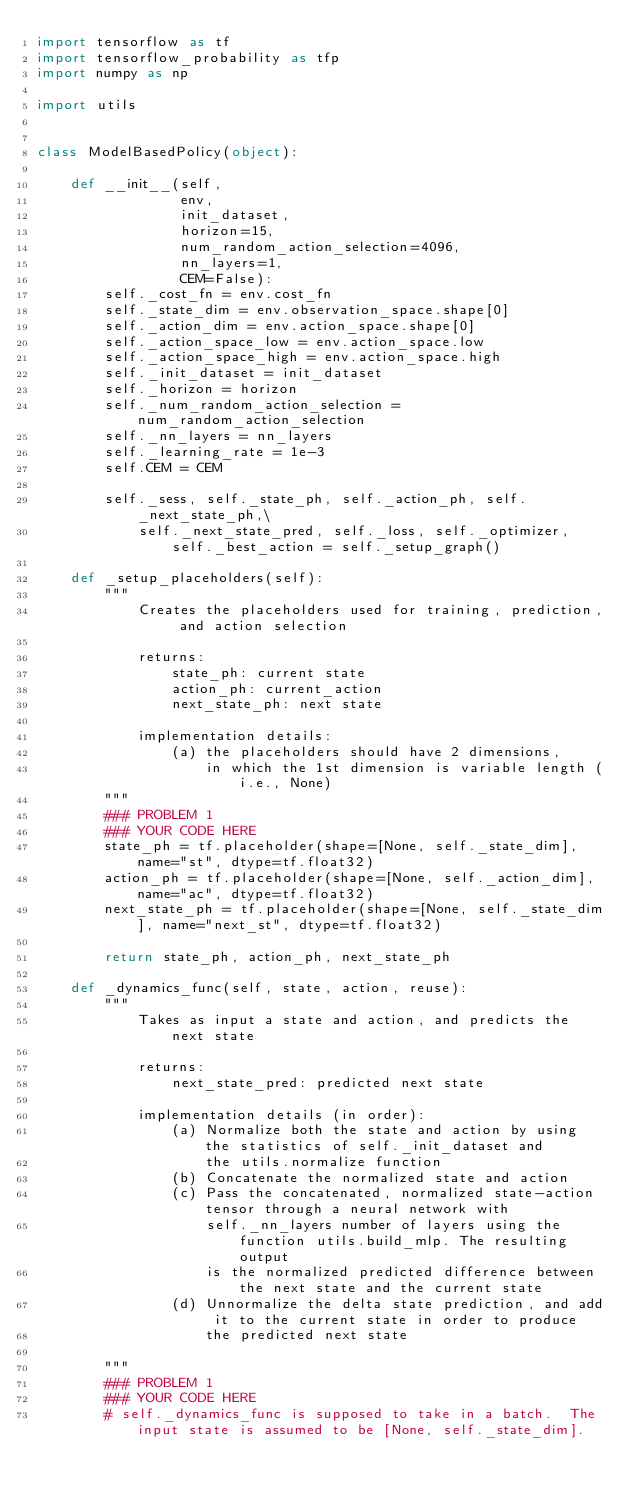Convert code to text. <code><loc_0><loc_0><loc_500><loc_500><_Python_>import tensorflow as tf
import tensorflow_probability as tfp
import numpy as np

import utils


class ModelBasedPolicy(object):

    def __init__(self,
                 env,
                 init_dataset,
                 horizon=15,
                 num_random_action_selection=4096,
                 nn_layers=1,
                 CEM=False):
        self._cost_fn = env.cost_fn
        self._state_dim = env.observation_space.shape[0]
        self._action_dim = env.action_space.shape[0]
        self._action_space_low = env.action_space.low
        self._action_space_high = env.action_space.high
        self._init_dataset = init_dataset
        self._horizon = horizon
        self._num_random_action_selection = num_random_action_selection
        self._nn_layers = nn_layers
        self._learning_rate = 1e-3
        self.CEM = CEM

        self._sess, self._state_ph, self._action_ph, self._next_state_ph,\
            self._next_state_pred, self._loss, self._optimizer, self._best_action = self._setup_graph()

    def _setup_placeholders(self):
        """
            Creates the placeholders used for training, prediction, and action selection

            returns:
                state_ph: current state
                action_ph: current_action
                next_state_ph: next state

            implementation details:
                (a) the placeholders should have 2 dimensions,
                    in which the 1st dimension is variable length (i.e., None)
        """
        ### PROBLEM 1
        ### YOUR CODE HERE
        state_ph = tf.placeholder(shape=[None, self._state_dim], name="st", dtype=tf.float32)
        action_ph = tf.placeholder(shape=[None, self._action_dim], name="ac", dtype=tf.float32)
        next_state_ph = tf.placeholder(shape=[None, self._state_dim], name="next_st", dtype=tf.float32)

        return state_ph, action_ph, next_state_ph

    def _dynamics_func(self, state, action, reuse):
        """
            Takes as input a state and action, and predicts the next state

            returns:
                next_state_pred: predicted next state

            implementation details (in order):
                (a) Normalize both the state and action by using the statistics of self._init_dataset and
                    the utils.normalize function
                (b) Concatenate the normalized state and action
                (c) Pass the concatenated, normalized state-action tensor through a neural network with
                    self._nn_layers number of layers using the function utils.build_mlp. The resulting output
                    is the normalized predicted difference between the next state and the current state
                (d) Unnormalize the delta state prediction, and add it to the current state in order to produce
                    the predicted next state

        """
        ### PROBLEM 1
        ### YOUR CODE HERE
        # self._dynamics_func is supposed to take in a batch.  The input state is assumed to be [None, self._state_dim].</code> 